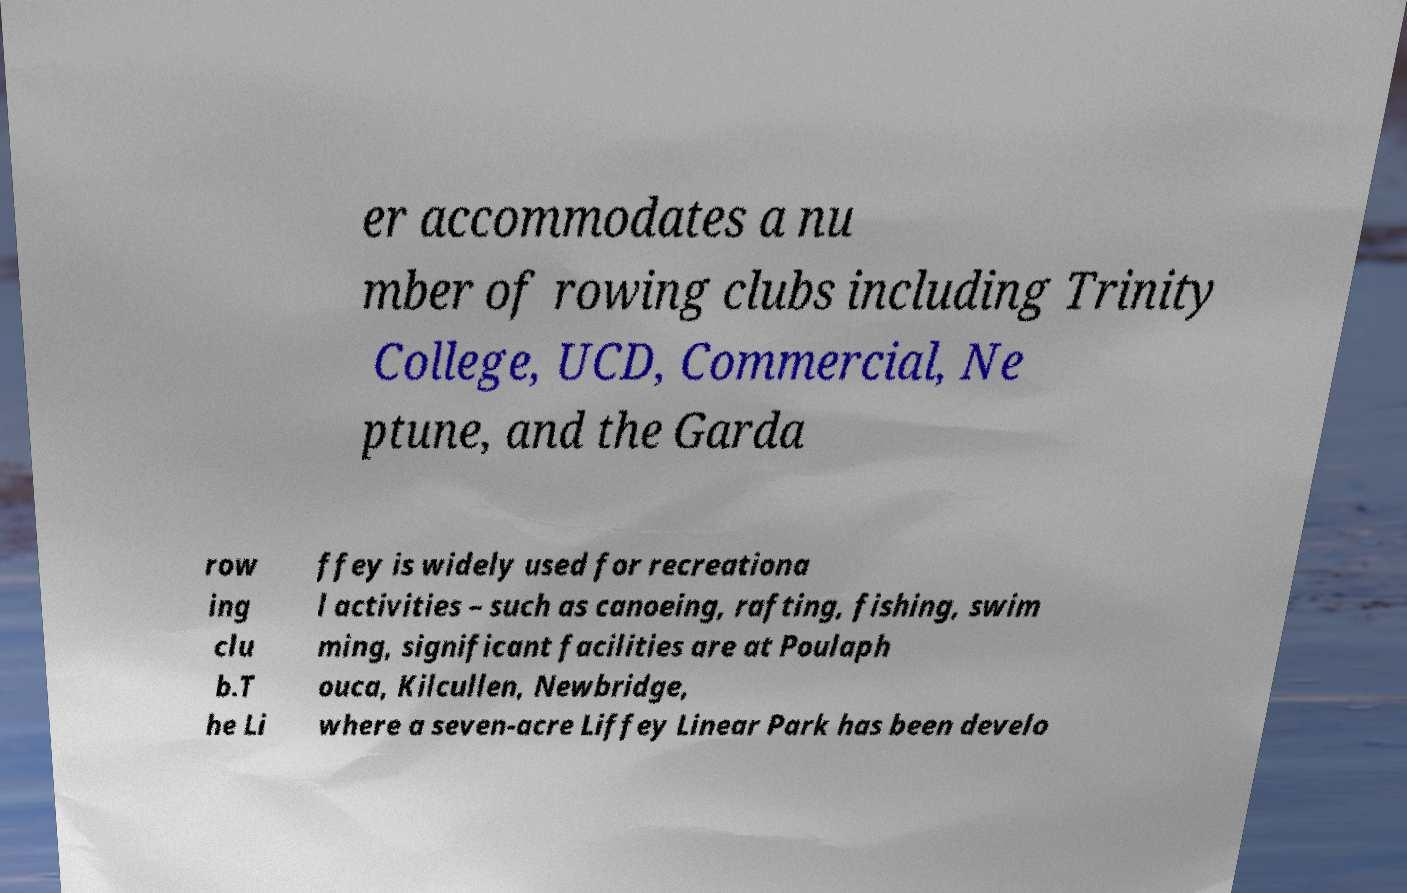Please identify and transcribe the text found in this image. er accommodates a nu mber of rowing clubs including Trinity College, UCD, Commercial, Ne ptune, and the Garda row ing clu b.T he Li ffey is widely used for recreationa l activities – such as canoeing, rafting, fishing, swim ming, significant facilities are at Poulaph ouca, Kilcullen, Newbridge, where a seven-acre Liffey Linear Park has been develo 